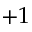<formula> <loc_0><loc_0><loc_500><loc_500>+ 1</formula> 